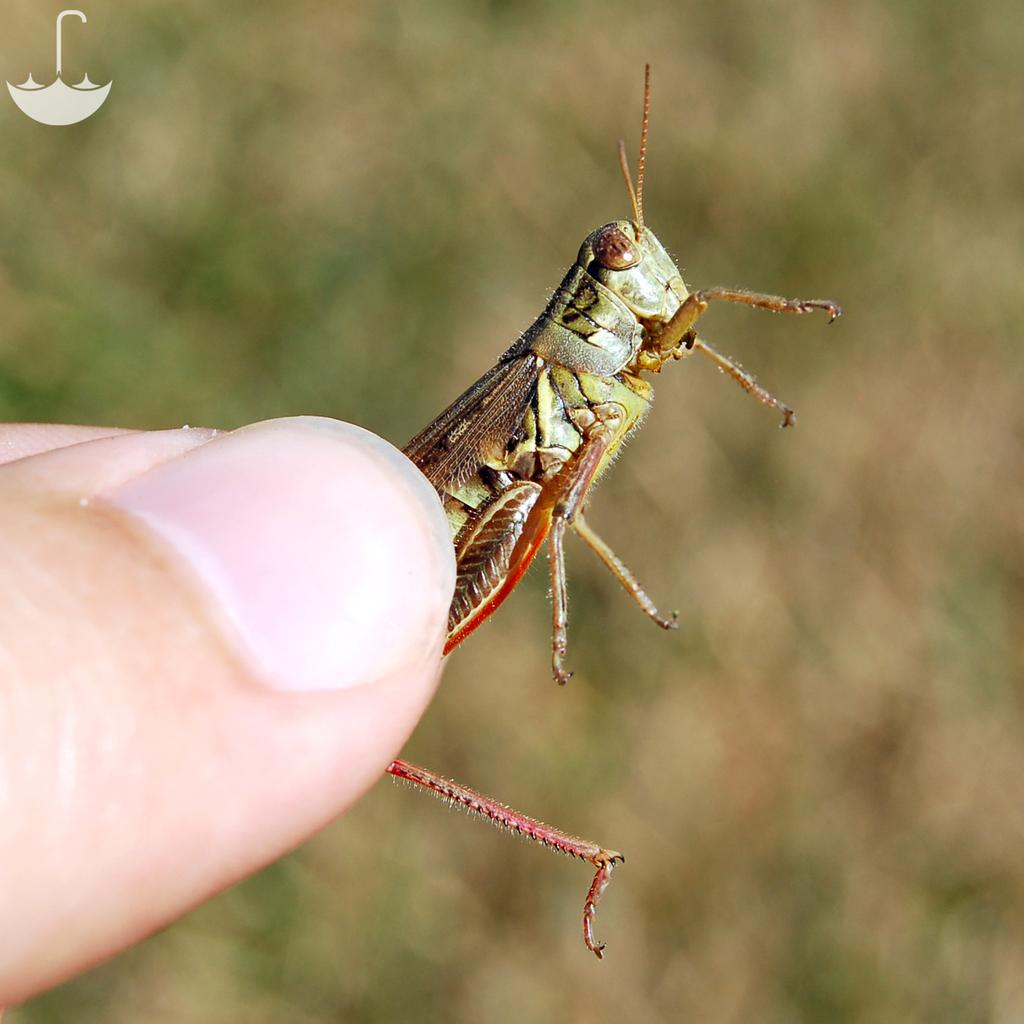Who or what is the main subject in the image? There is a person in the image. What is the person holding in the image? The person is holding an insect. Can you describe anything in the background of the image? There is a logo visible in the background of the image. Where is the kitty hiding in the image? There is no kitty present in the image. What type of deer can be seen in the background of the image? There is no deer present in the image; only a logo is visible in the background. 